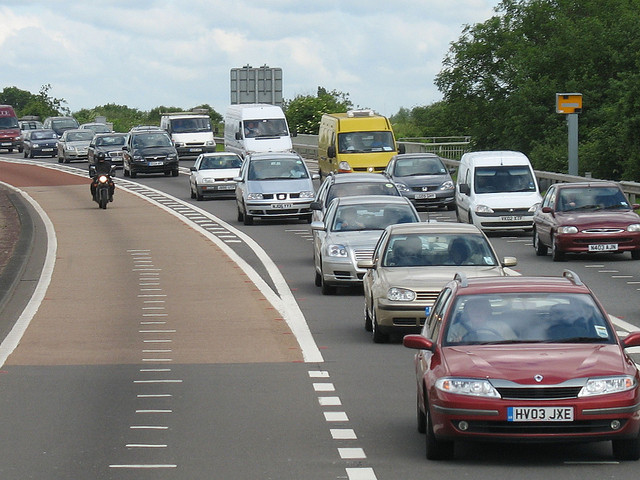Identify the text contained in this image. HV03 JXE 